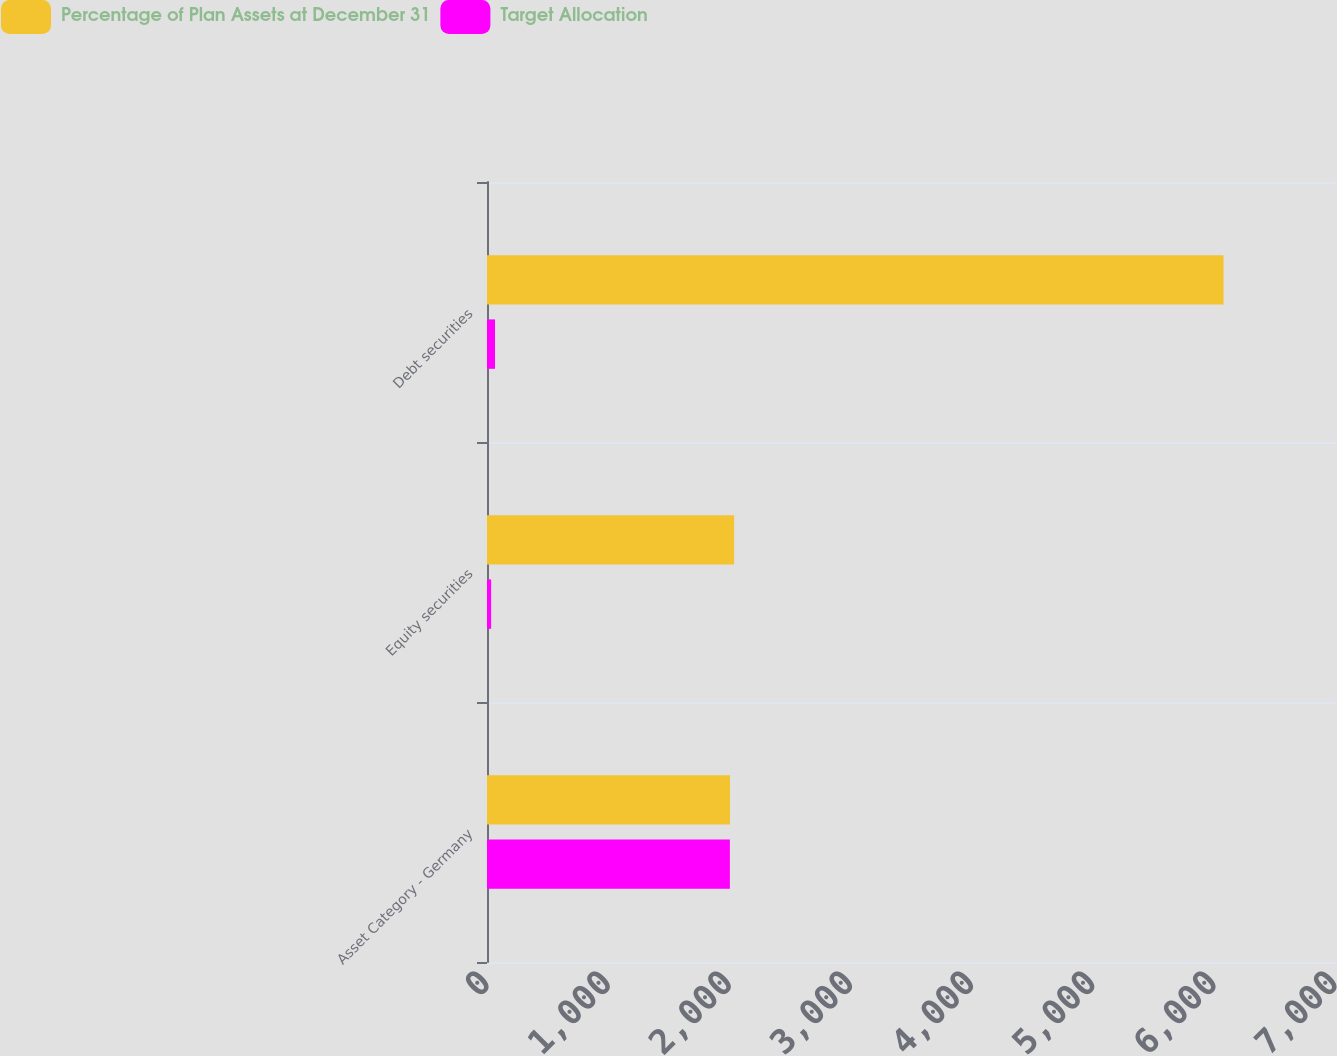<chart> <loc_0><loc_0><loc_500><loc_500><stacked_bar_chart><ecel><fcel>Asset Category - Germany<fcel>Equity securities<fcel>Debt securities<nl><fcel>Percentage of Plan Assets at December 31<fcel>2006<fcel>2040<fcel>6080<nl><fcel>Target Allocation<fcel>2005<fcel>34<fcel>66<nl></chart> 